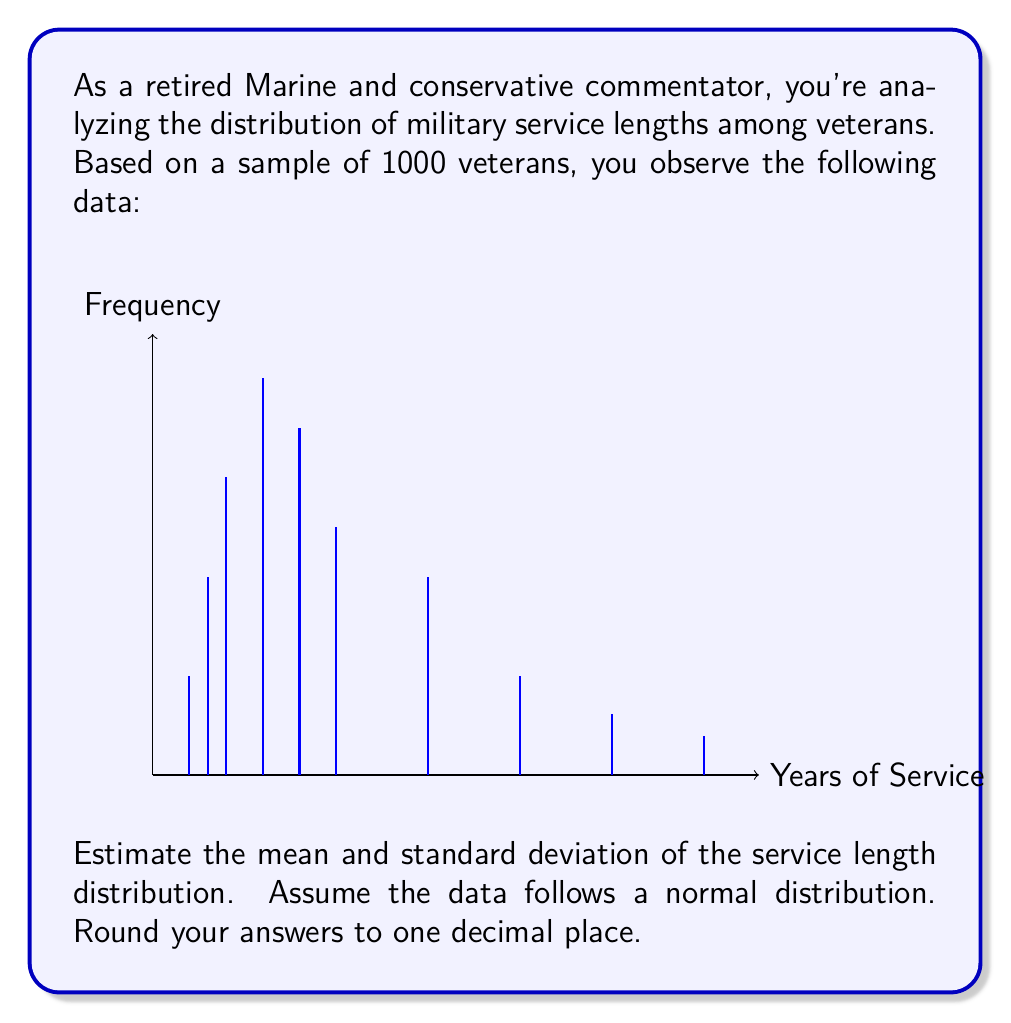Teach me how to tackle this problem. To estimate the mean and standard deviation, we'll use the following steps:

1) Calculate the mean (μ):
   $$ \mu = \frac{\sum_{i=1}^{n} f_i x_i}{\sum_{i=1}^{n} f_i} $$
   where $f_i$ is the frequency and $x_i$ is the service length.

2) Calculate the variance (σ²):
   $$ \sigma^2 = \frac{\sum_{i=1}^{n} f_i (x_i - \mu)^2}{\sum_{i=1}^{n} f_i} $$

3) Take the square root of the variance to get the standard deviation (σ).

Step 1: Calculating the mean
$$ \mu = \frac{(2\cdot50 + 3\cdot100 + 4\cdot150 + 6\cdot200 + 8\cdot175 + 10\cdot125 + 15\cdot100 + 20\cdot50 + 25\cdot30 + 30\cdot20)}{1000} $$
$$ \mu = \frac{8275}{1000} = 8.275 \approx 8.3 \text{ years} $$

Step 2: Calculating the variance
$$ \sigma^2 = \frac{50(2-8.3)^2 + 100(3-8.3)^2 + 150(4-8.3)^2 + 200(6-8.3)^2 + 175(8-8.3)^2 + 125(10-8.3)^2 + 100(15-8.3)^2 + 50(20-8.3)^2 + 30(25-8.3)^2 + 20(30-8.3)^2}{1000} $$
$$ \sigma^2 = 39.8975 $$

Step 3: Calculating the standard deviation
$$ \sigma = \sqrt{39.8975} \approx 6.3 \text{ years} $$
Answer: Mean: 8.3 years, Standard Deviation: 6.3 years 